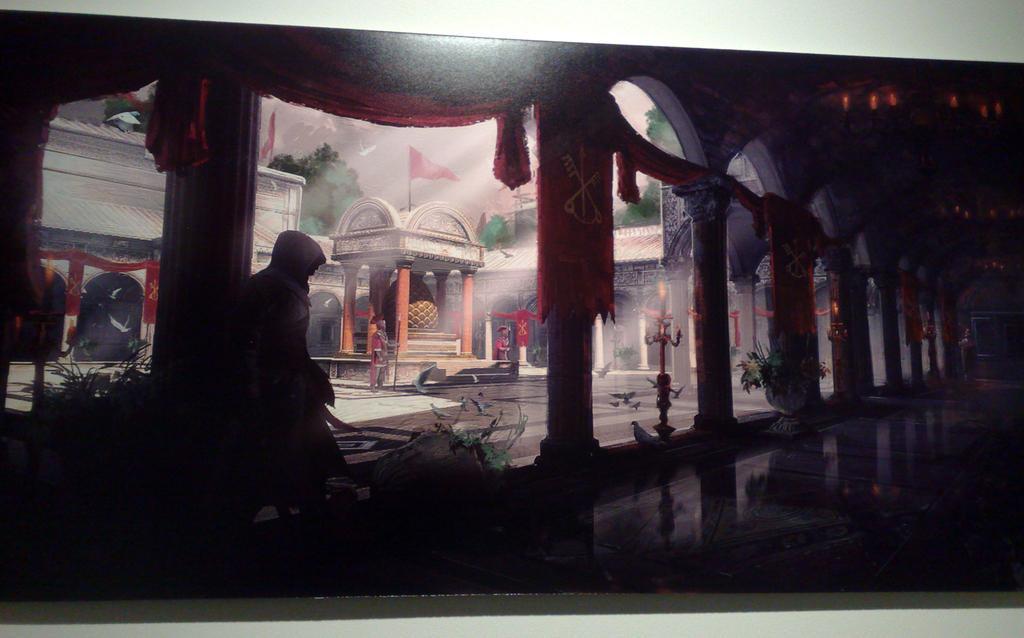In one or two sentences, can you explain what this image depicts? In this image we can see statues, plants, pillars, buildings, flags, trees, and sky. Here we can see a person. 